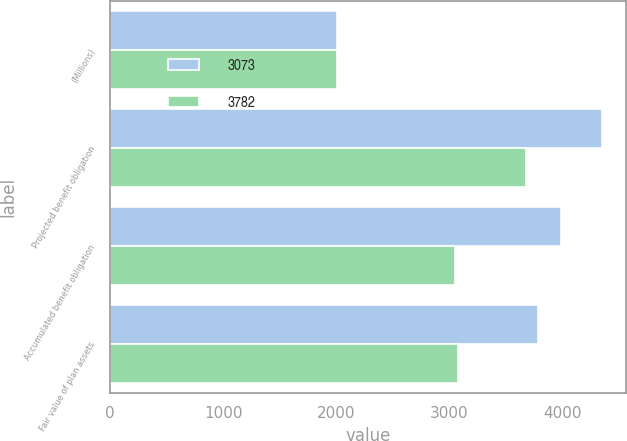<chart> <loc_0><loc_0><loc_500><loc_500><stacked_bar_chart><ecel><fcel>(Millions)<fcel>Projected benefit obligation<fcel>Accumulated benefit obligation<fcel>Fair value of plan assets<nl><fcel>3073<fcel>2007<fcel>4346<fcel>3989<fcel>3782<nl><fcel>3782<fcel>2006<fcel>3680<fcel>3049<fcel>3073<nl></chart> 